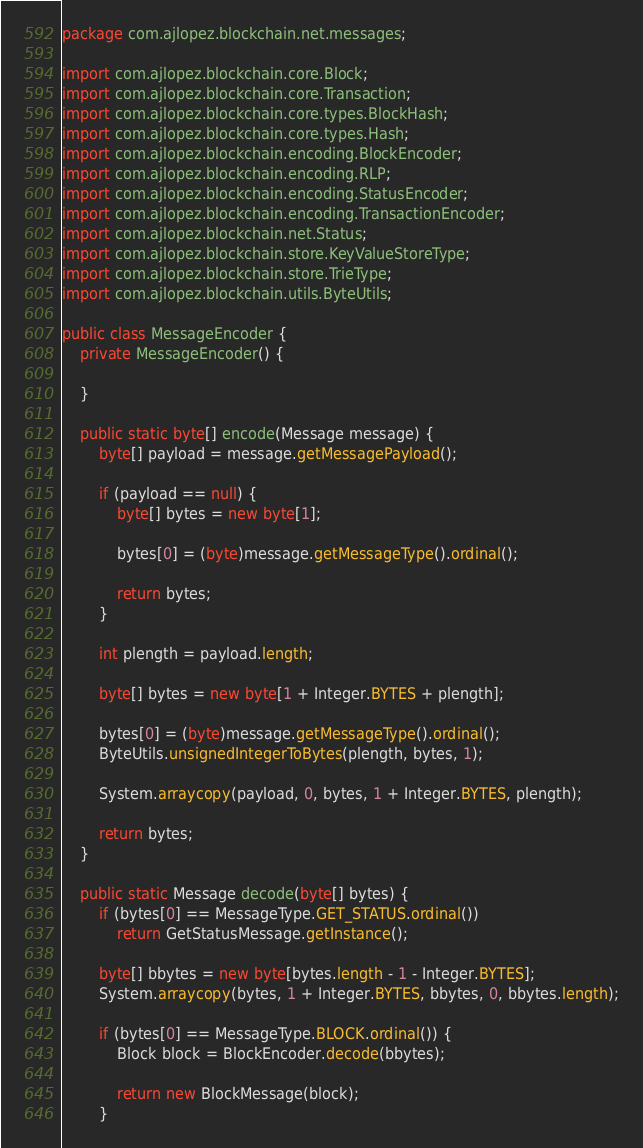<code> <loc_0><loc_0><loc_500><loc_500><_Java_>package com.ajlopez.blockchain.net.messages;

import com.ajlopez.blockchain.core.Block;
import com.ajlopez.blockchain.core.Transaction;
import com.ajlopez.blockchain.core.types.BlockHash;
import com.ajlopez.blockchain.core.types.Hash;
import com.ajlopez.blockchain.encoding.BlockEncoder;
import com.ajlopez.blockchain.encoding.RLP;
import com.ajlopez.blockchain.encoding.StatusEncoder;
import com.ajlopez.blockchain.encoding.TransactionEncoder;
import com.ajlopez.blockchain.net.Status;
import com.ajlopez.blockchain.store.KeyValueStoreType;
import com.ajlopez.blockchain.store.TrieType;
import com.ajlopez.blockchain.utils.ByteUtils;

public class MessageEncoder {
    private MessageEncoder() {

    }

    public static byte[] encode(Message message) {
        byte[] payload = message.getMessagePayload();

        if (payload == null) {
            byte[] bytes = new byte[1];

            bytes[0] = (byte)message.getMessageType().ordinal();

            return bytes;
        }

        int plength = payload.length;

        byte[] bytes = new byte[1 + Integer.BYTES + plength];

        bytes[0] = (byte)message.getMessageType().ordinal();
        ByteUtils.unsignedIntegerToBytes(plength, bytes, 1);

        System.arraycopy(payload, 0, bytes, 1 + Integer.BYTES, plength);

        return bytes;
    }

    public static Message decode(byte[] bytes) {
        if (bytes[0] == MessageType.GET_STATUS.ordinal())
            return GetStatusMessage.getInstance();

        byte[] bbytes = new byte[bytes.length - 1 - Integer.BYTES];
        System.arraycopy(bytes, 1 + Integer.BYTES, bbytes, 0, bbytes.length);

        if (bytes[0] == MessageType.BLOCK.ordinal()) {
            Block block = BlockEncoder.decode(bbytes);

            return new BlockMessage(block);
        }
</code> 